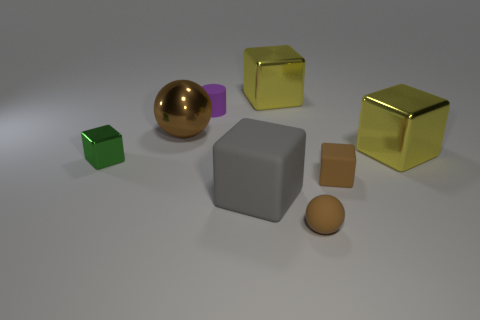What is the green object made of?
Your response must be concise. Metal. What color is the big shiny thing that is behind the purple cylinder?
Your response must be concise. Yellow. What number of large objects are either green shiny objects or red cylinders?
Offer a very short reply. 0. There is a large object left of the large matte block; is it the same color as the rubber object that is in front of the big gray matte object?
Your response must be concise. Yes. What number of other things are the same color as the tiny metal cube?
Make the answer very short. 0. How many purple objects are small shiny things or small cylinders?
Your answer should be compact. 1. Does the big gray rubber thing have the same shape as the object that is behind the small purple cylinder?
Provide a short and direct response. Yes. There is a purple object; what shape is it?
Make the answer very short. Cylinder. There is a brown sphere that is the same size as the brown cube; what is it made of?
Your answer should be very brief. Rubber. What number of objects are small rubber things or big metallic objects that are to the right of the gray rubber object?
Provide a short and direct response. 5. 